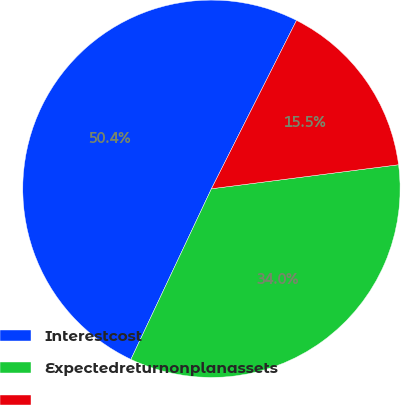<chart> <loc_0><loc_0><loc_500><loc_500><pie_chart><fcel>Interestcost<fcel>Expectedreturnonplanassets<fcel>Unnamed: 2<nl><fcel>50.43%<fcel>34.05%<fcel>15.52%<nl></chart> 